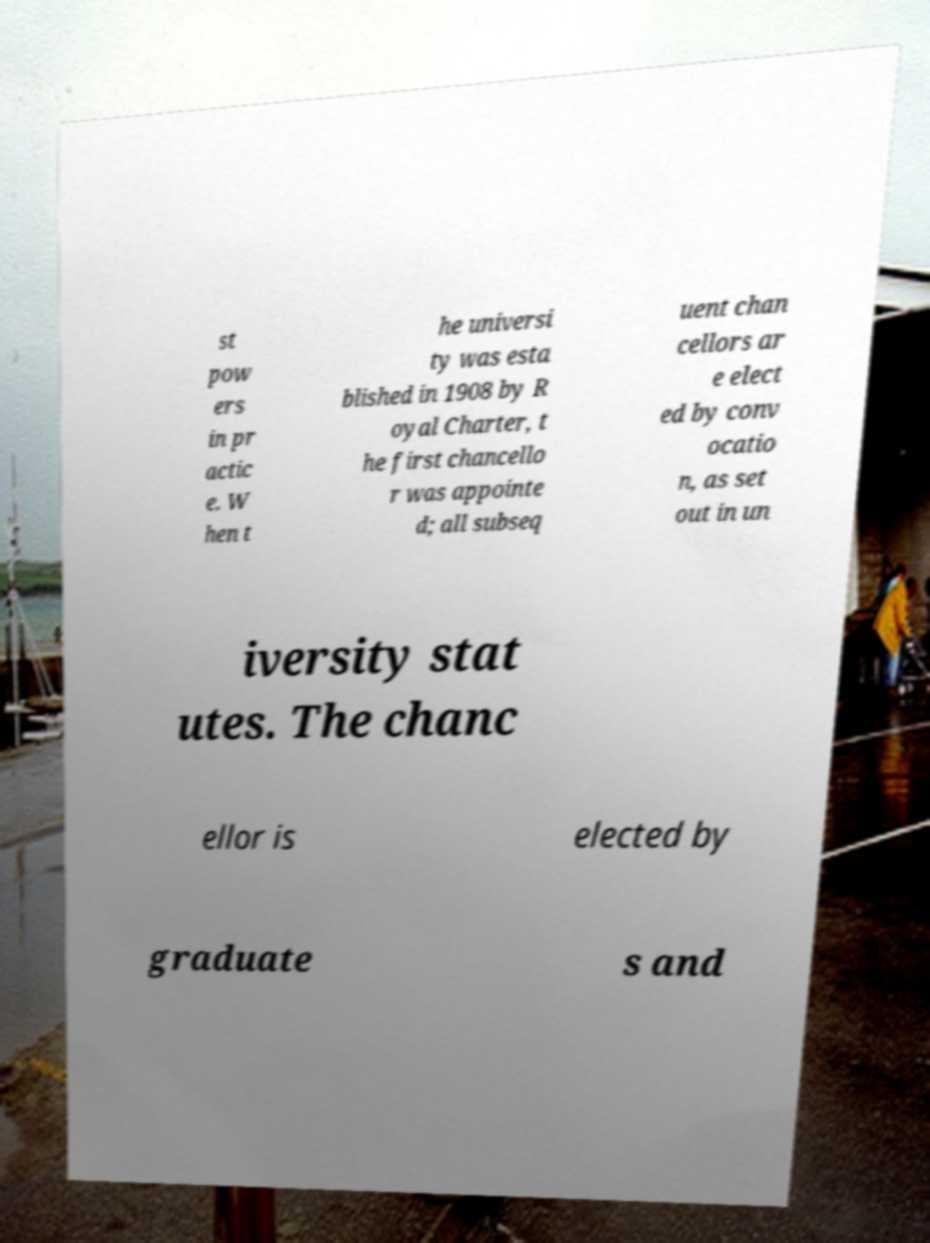Could you extract and type out the text from this image? st pow ers in pr actic e. W hen t he universi ty was esta blished in 1908 by R oyal Charter, t he first chancello r was appointe d; all subseq uent chan cellors ar e elect ed by conv ocatio n, as set out in un iversity stat utes. The chanc ellor is elected by graduate s and 